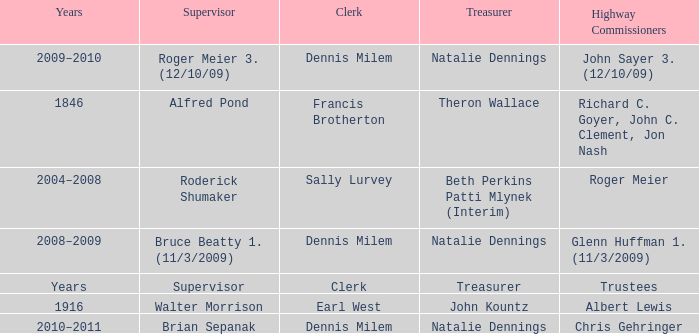When Treasurer was treasurer, who was the highway commissioner? Trustees. 